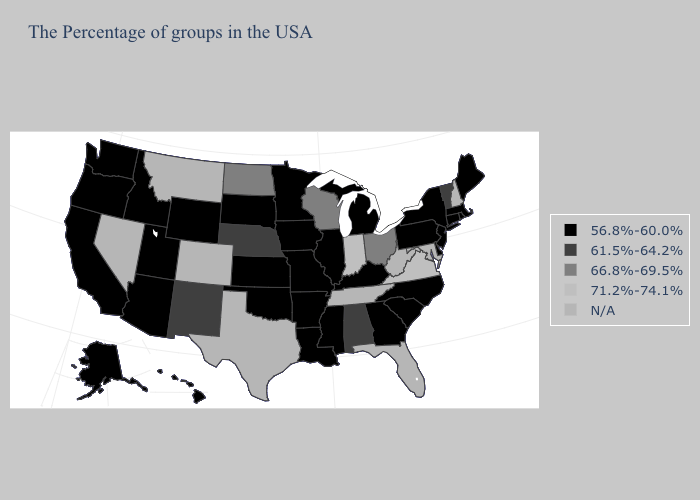What is the value of Nevada?
Be succinct. N/A. What is the value of Kansas?
Keep it brief. 56.8%-60.0%. Does California have the lowest value in the USA?
Short answer required. Yes. Does Nebraska have the lowest value in the MidWest?
Answer briefly. No. Does Arizona have the lowest value in the West?
Give a very brief answer. Yes. What is the highest value in the Northeast ?
Give a very brief answer. 61.5%-64.2%. What is the lowest value in the Northeast?
Answer briefly. 56.8%-60.0%. Name the states that have a value in the range N/A?
Answer briefly. New Hampshire, Maryland, West Virginia, Florida, Tennessee, Texas, Colorado, Montana, Nevada. How many symbols are there in the legend?
Be succinct. 5. Among the states that border Montana , does Idaho have the highest value?
Concise answer only. No. Does Pennsylvania have the lowest value in the USA?
Short answer required. Yes. Name the states that have a value in the range 71.2%-74.1%?
Write a very short answer. Virginia, Indiana. What is the value of Idaho?
Concise answer only. 56.8%-60.0%. Among the states that border Texas , does New Mexico have the highest value?
Keep it brief. Yes. 